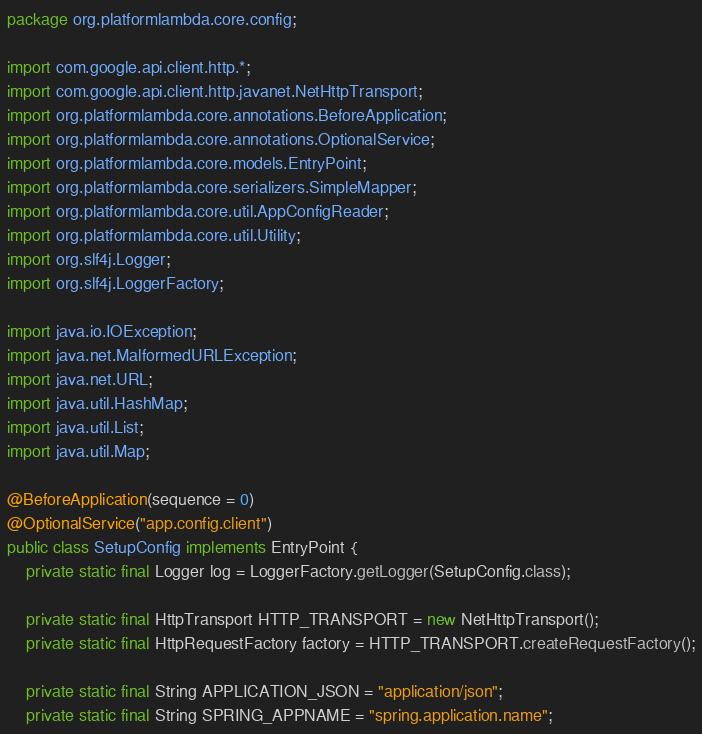Convert code to text. <code><loc_0><loc_0><loc_500><loc_500><_Java_>package org.platformlambda.core.config;

import com.google.api.client.http.*;
import com.google.api.client.http.javanet.NetHttpTransport;
import org.platformlambda.core.annotations.BeforeApplication;
import org.platformlambda.core.annotations.OptionalService;
import org.platformlambda.core.models.EntryPoint;
import org.platformlambda.core.serializers.SimpleMapper;
import org.platformlambda.core.util.AppConfigReader;
import org.platformlambda.core.util.Utility;
import org.slf4j.Logger;
import org.slf4j.LoggerFactory;

import java.io.IOException;
import java.net.MalformedURLException;
import java.net.URL;
import java.util.HashMap;
import java.util.List;
import java.util.Map;

@BeforeApplication(sequence = 0)
@OptionalService("app.config.client")
public class SetupConfig implements EntryPoint {
    private static final Logger log = LoggerFactory.getLogger(SetupConfig.class);

    private static final HttpTransport HTTP_TRANSPORT = new NetHttpTransport();
    private static final HttpRequestFactory factory = HTTP_TRANSPORT.createRequestFactory();

    private static final String APPLICATION_JSON = "application/json";
    private static final String SPRING_APPNAME = "spring.application.name";</code> 